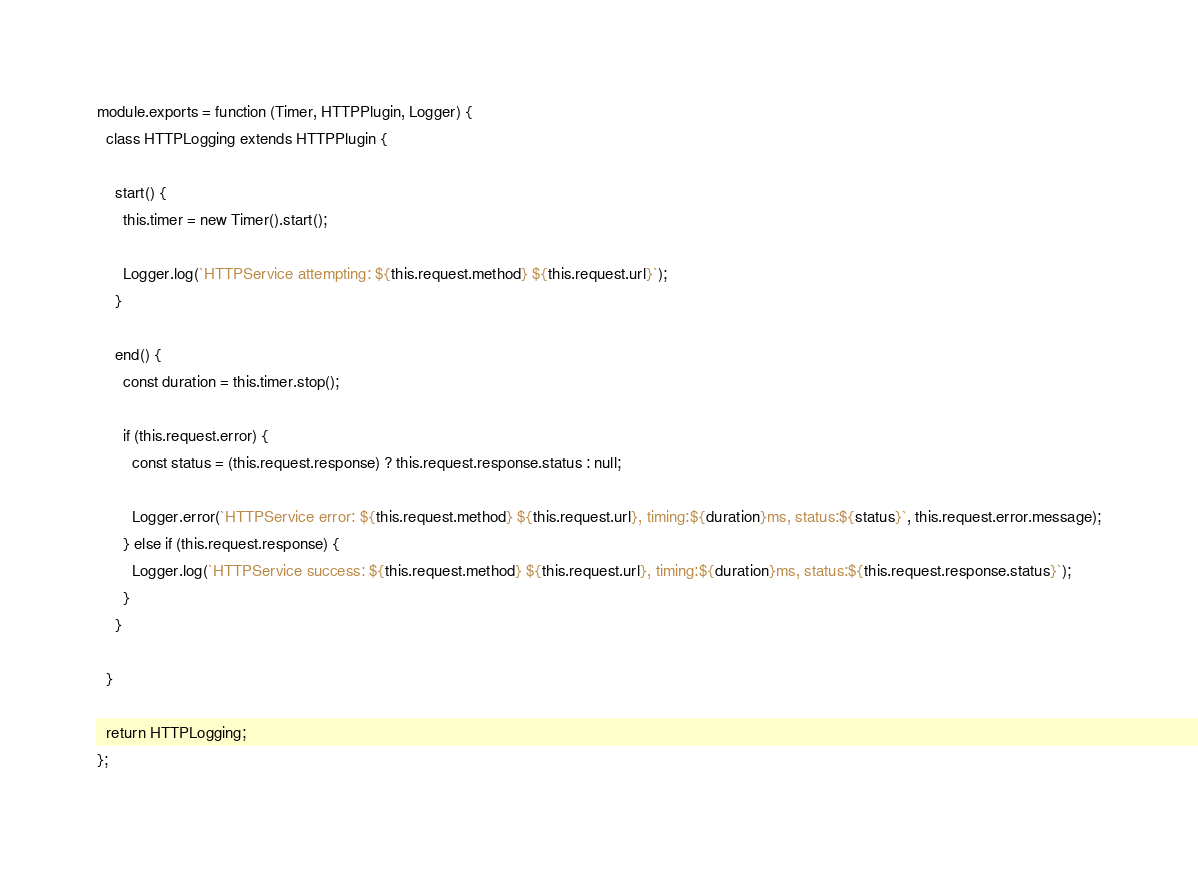Convert code to text. <code><loc_0><loc_0><loc_500><loc_500><_JavaScript_>module.exports = function (Timer, HTTPPlugin, Logger) {
  class HTTPLogging extends HTTPPlugin {

    start() {
      this.timer = new Timer().start();

      Logger.log(`HTTPService attempting: ${this.request.method} ${this.request.url}`);
    }

    end() {
      const duration = this.timer.stop();

      if (this.request.error) {
        const status = (this.request.response) ? this.request.response.status : null;

        Logger.error(`HTTPService error: ${this.request.method} ${this.request.url}, timing:${duration}ms, status:${status}`, this.request.error.message);
      } else if (this.request.response) {
        Logger.log(`HTTPService success: ${this.request.method} ${this.request.url}, timing:${duration}ms, status:${this.request.response.status}`);
      }
    }

  }

  return HTTPLogging;
};
</code> 